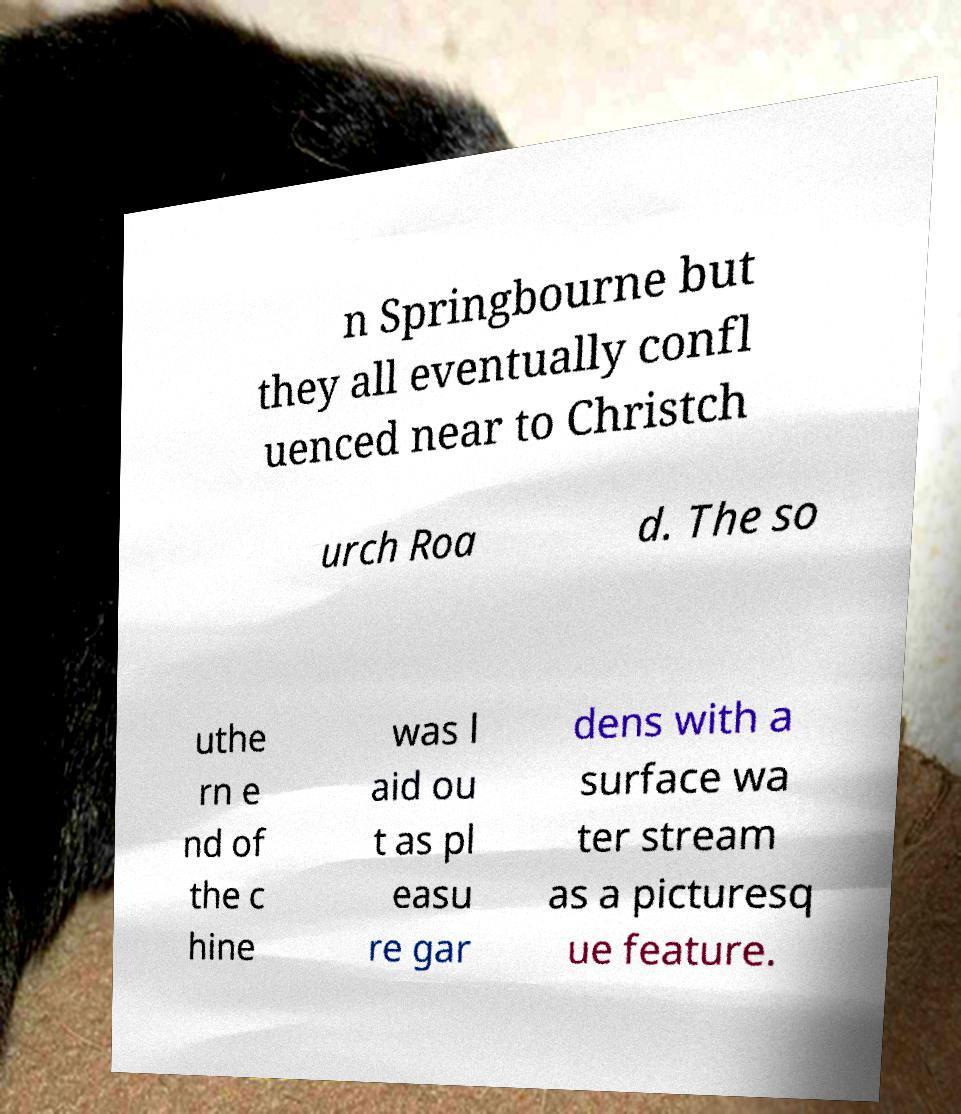Can you accurately transcribe the text from the provided image for me? n Springbourne but they all eventually confl uenced near to Christch urch Roa d. The so uthe rn e nd of the c hine was l aid ou t as pl easu re gar dens with a surface wa ter stream as a picturesq ue feature. 